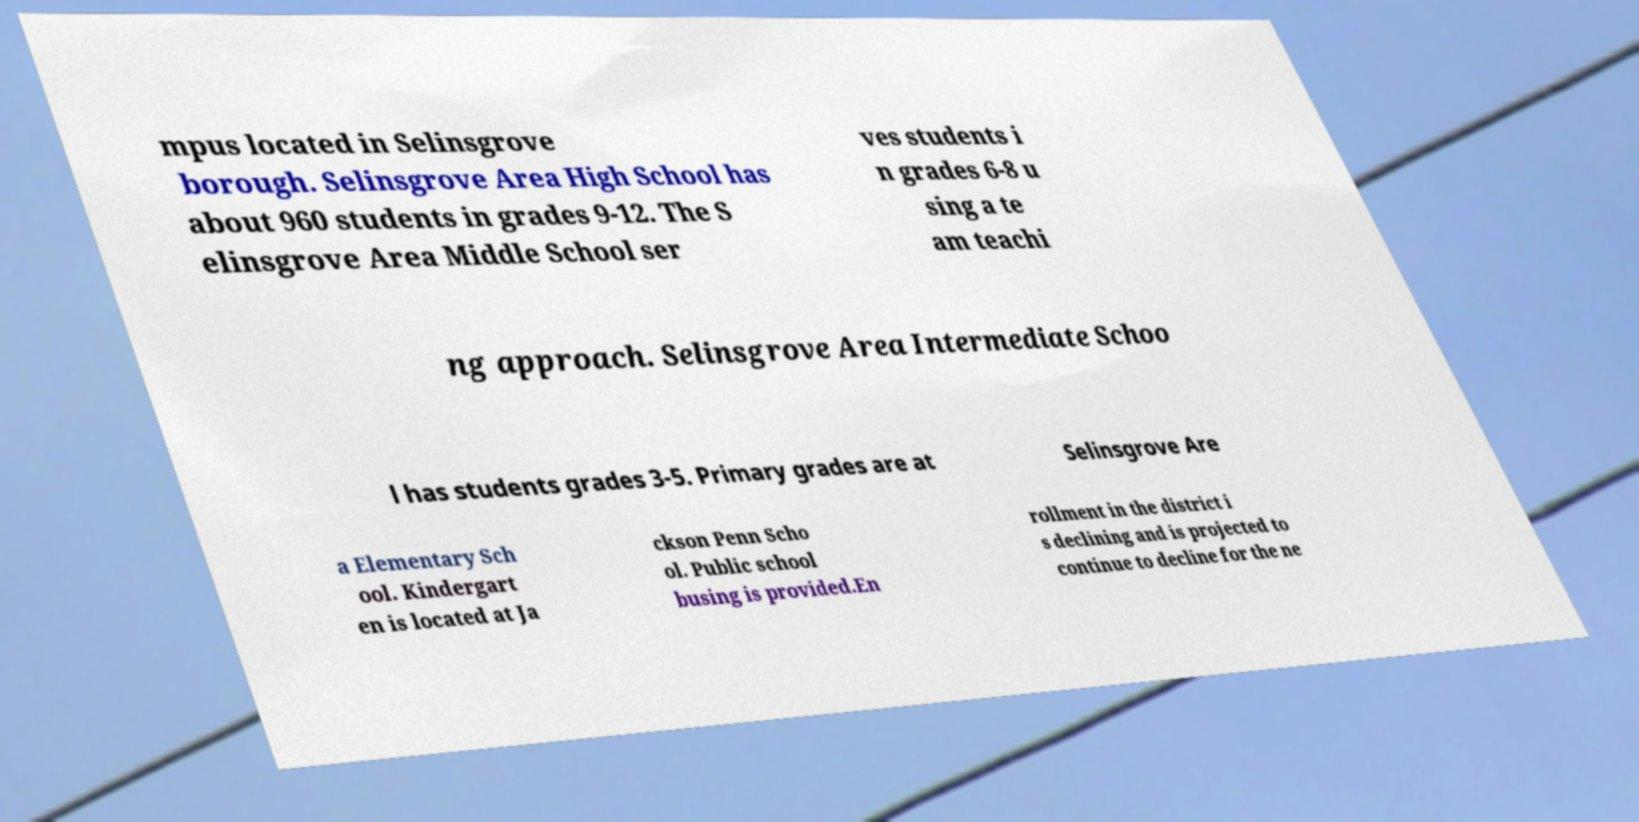What messages or text are displayed in this image? I need them in a readable, typed format. mpus located in Selinsgrove borough. Selinsgrove Area High School has about 960 students in grades 9-12. The S elinsgrove Area Middle School ser ves students i n grades 6-8 u sing a te am teachi ng approach. Selinsgrove Area Intermediate Schoo l has students grades 3-5. Primary grades are at Selinsgrove Are a Elementary Sch ool. Kindergart en is located at Ja ckson Penn Scho ol. Public school busing is provided.En rollment in the district i s declining and is projected to continue to decline for the ne 